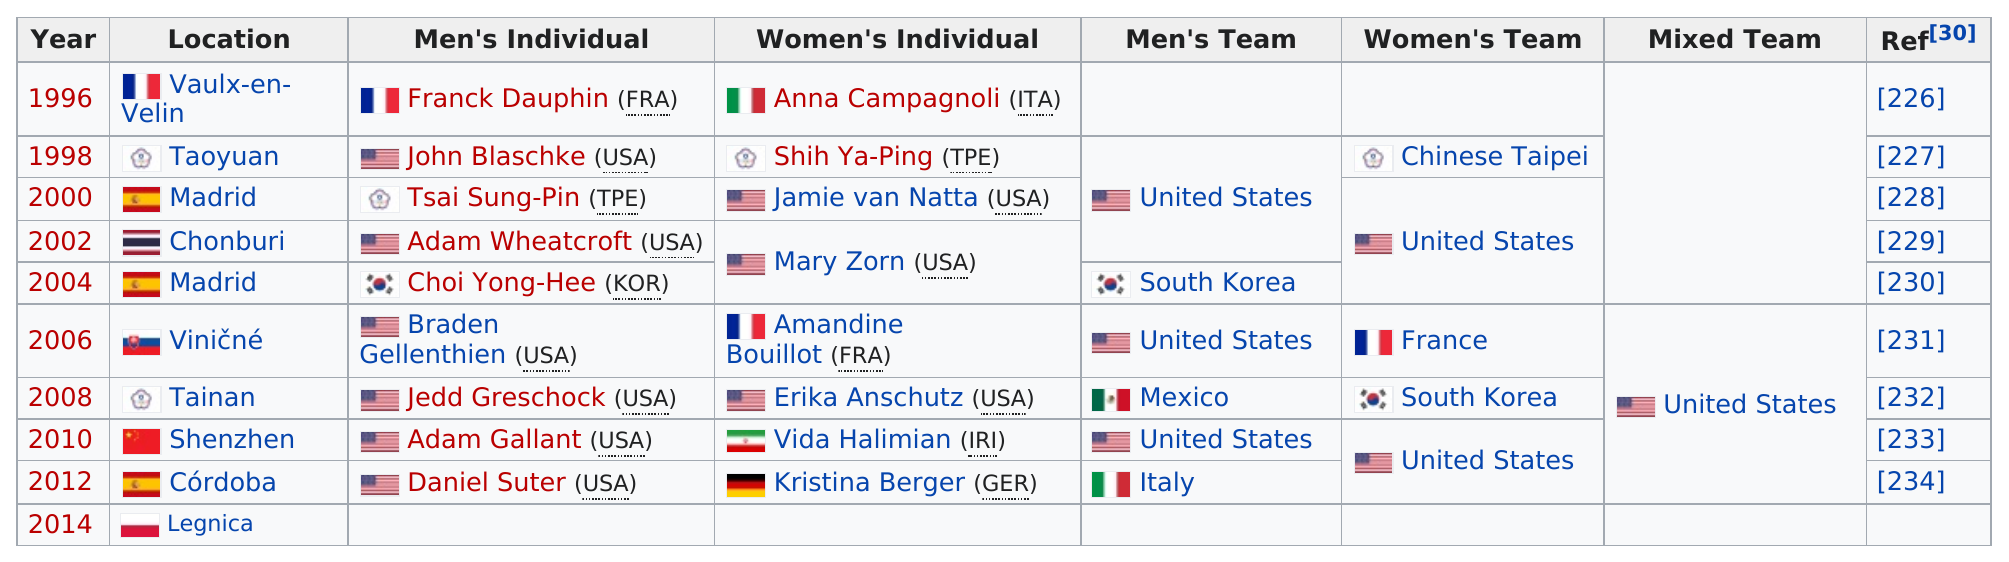Point out several critical features in this image. The location was in Madrid a total of two times. France is the only country in Europe that has won the women's team championship. The United States women's team won the last competition. In the year 2008, an American man or woman won both the individual men's and women's Olympic gold medals. The United States appears under the men's team column three times. 